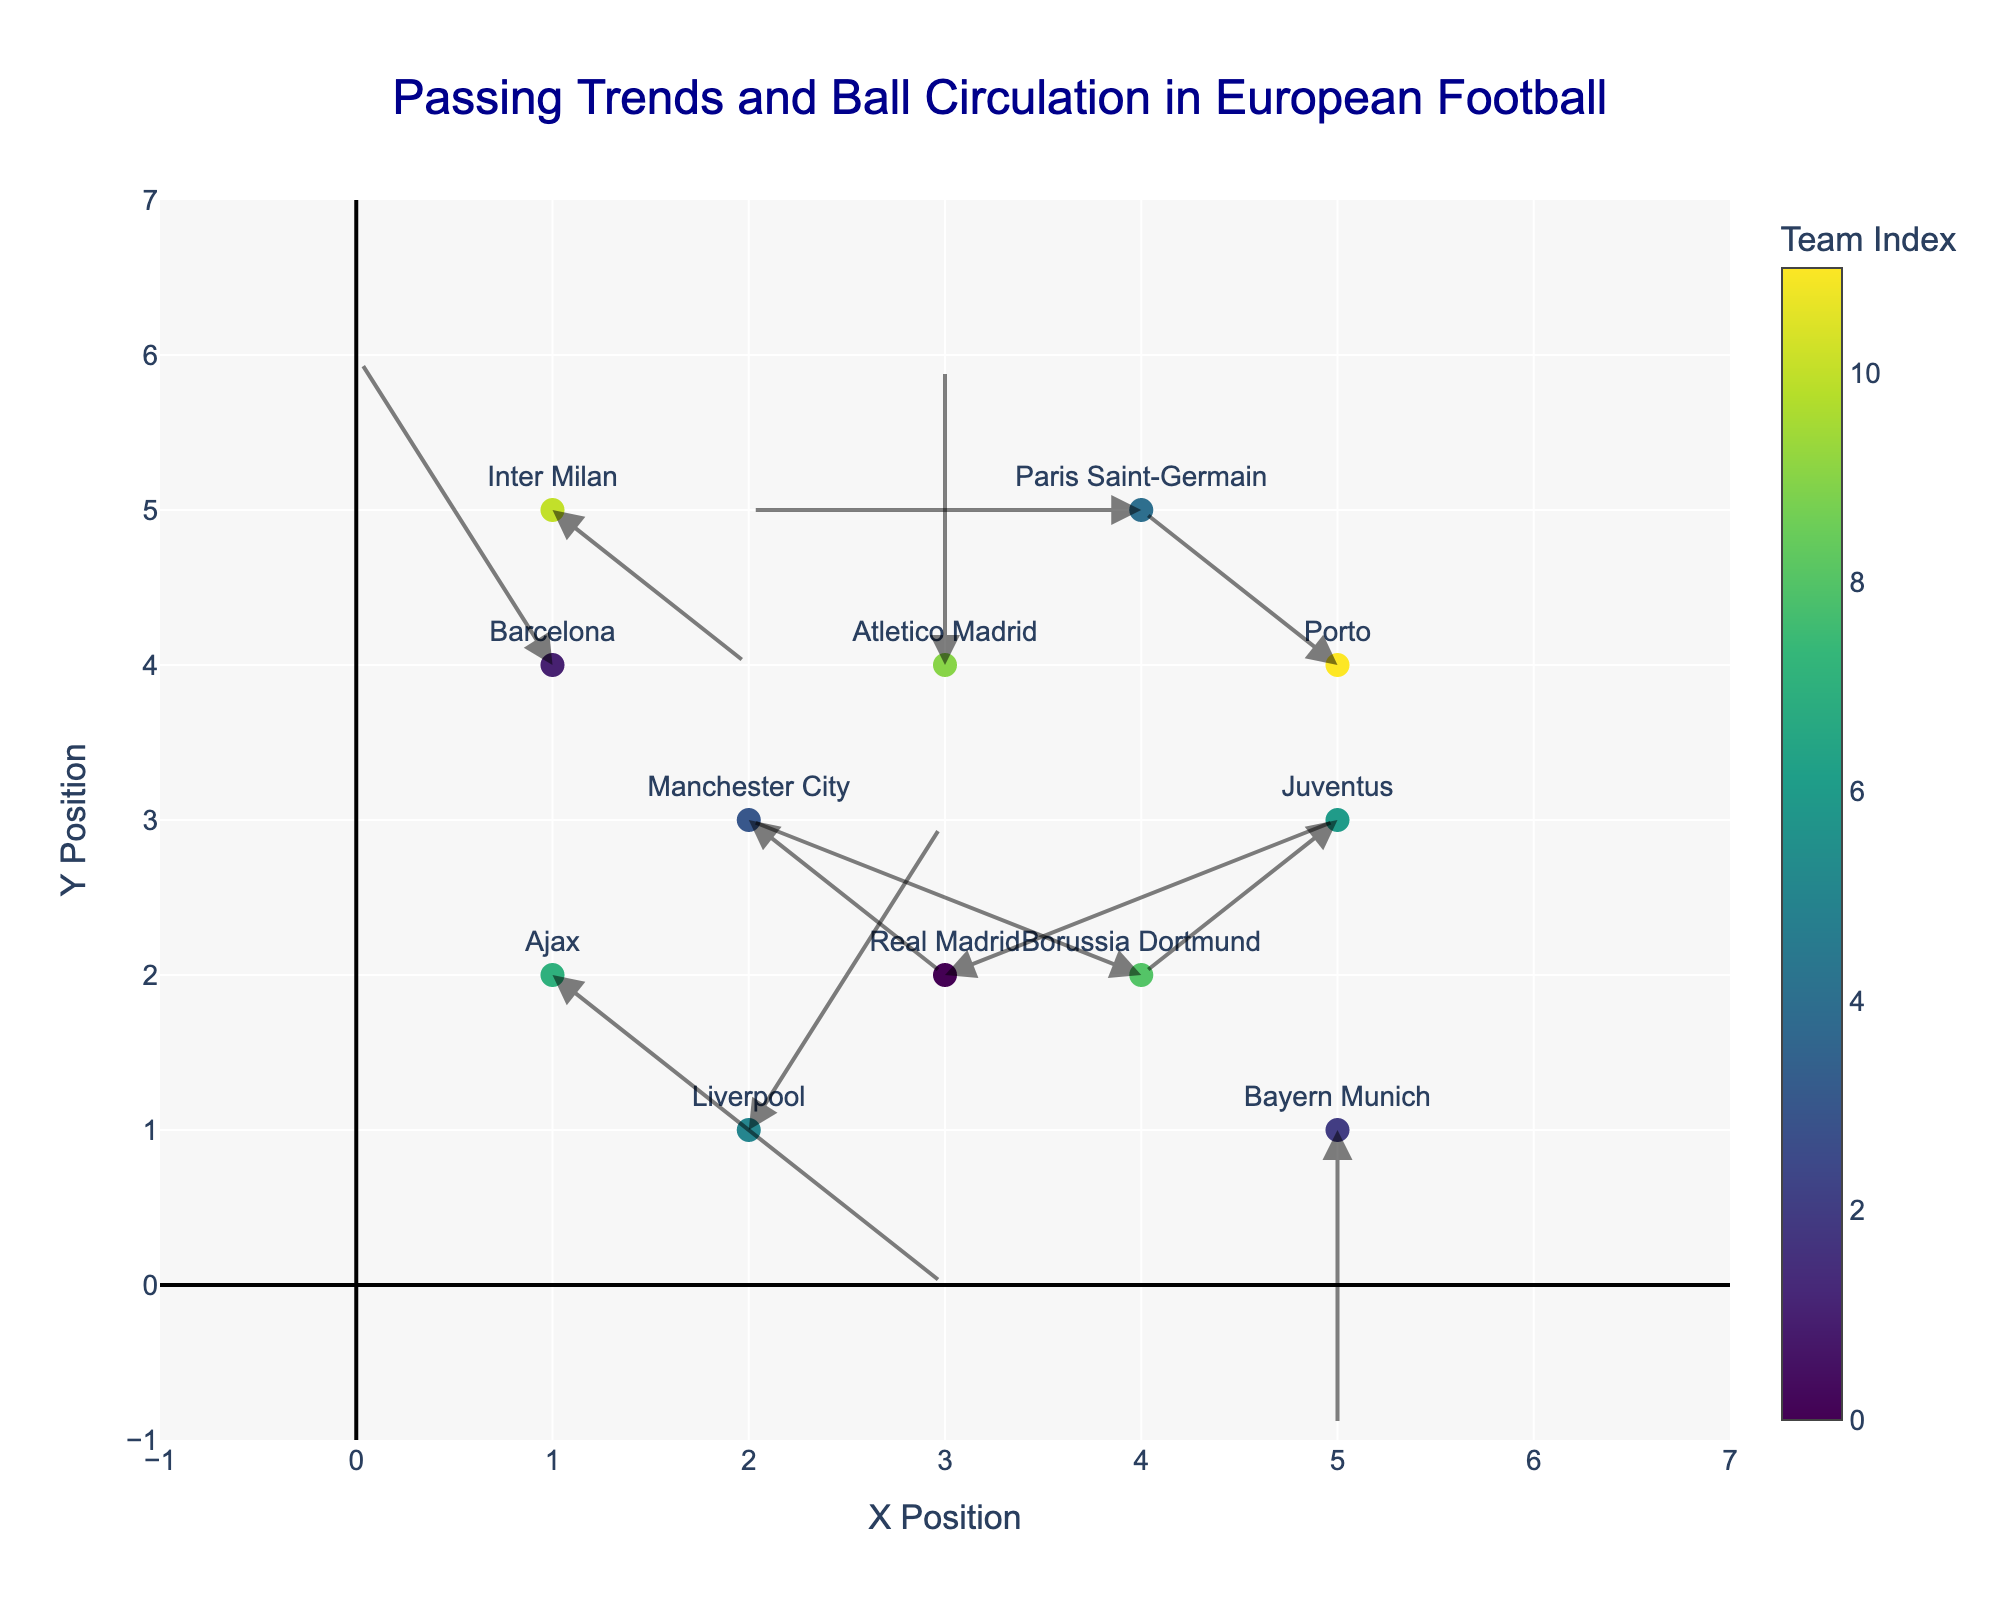What is the title of the figure? The title of the figure is displayed at the top of the plot area, and it is formatted with a larger font size and a distinct color to make it stand out. It reads, "Passing Trends and Ball Circulation in European Football."
Answer: Passing Trends and Ball Circulation in European Football How many teams are represented in the figure? Count the number of distinct markers (both points and arrows) with team names beside them. The data includes multiple teams, so you need to cross-check with the annotations to confirm the count.
Answer: 12 Which team has a passing direction exactly along the y-axis? Look for a team whose arrow direction represents zero horizontal movement (u=0) and some vertical movement. In this case, examine the arrows to find Bayern Munich (u=0, v=-2).
Answer: Bayern Munich Which team has a negative horizontal passing trend but no vertical movement? Look for the team whose horizontal component (u) is negative and vertical component (v) is zero. Paris Saint-Germain fits this description with (u=-2, v=0).
Answer: Paris Saint-Germain Compare the passing trends of Ajax and Inter Milan. Which team shows a downward trend in their passing? Analyze the direction of the arrows for both teams. Ajax has and Inter Milan has determining the downward trend through v and y components. Note Ajax has (u=2, v=-2) showing downward movement while Inter Milan has (u=1, v=-1) also showing a downward trend. So both show downward trends but Ajax has a steeper one.
Answer: Both, but Ajax has a steeper downward trend What is the overall movement (u, v) of Real Madrid and how does it compare to Liverpool's movement? For Real Madrid, we have (u=2, v=1) and for Liverpool, (u=1, v=2). Comparing both vectors, Real Madrid has a more horizontal movement while Liverpool has a stronger vertical movement.
Answer: Real Madrid has more horizontal movement; Liverpool has more vertical movement What's the combined passing vector (u, v) for all the teams with negative horizontal passing trends? First identify teams with negative u, those are Barcelona (u=-1), Paris Saint-Germain (u=-2), Juventus (u=-1), Borussia Dortmund (u=-2), Porto (u=-1). Then sum their u and v components:
u_total = -1 + -2 + -1 + -2 + -1 = -7;
v_total = 2 + 0 + -1 + 1 + 1 = 3
Answer: (-7, 3) Which team has the most variability in both its x and y components (furthest vector)? Identify the team with the greatest combined movement in u and v by computing the magnitude (sqrt(u^2 + v^2)). Check each team's movement:
- Real Madrid: sqrt(2^2 + 1^2) = sqrt(5)
- Barcelona: sqrt((-1)^2 + 2^2) = sqrt(5)
- Bayern Munich: sqrt(0^2 + (-2)^2) = 2
- Manchester City: sqrt(1^2 + (-1)^2) = sqrt(2)
- Paris Saint-Germain: sqrt((-2)^2 + 0^2) = 2
- Liverpool: sqrt(1^2 + 2^2) = sqrt(5)
- Juventus: sqrt((-1)^2 + (-1)^2) = sqrt(2)
- Ajax: sqrt(2^2 + (-2)^2) = sqrt(8)
- Borussia Dortmund: sqrt((-2)^2 + 1^2) = sqrt(5)
- Atletico Madrid: sqrt(0^2 + 2^2) = 2
- Inter Milan: sqrt(1^2 + (-1)^2) = sqrt(2)
- Porto: sqrt((-1)^2 + 1^2) = sqrt(2)
Ajax has the highest variability with sqrt(8) ≈ 2.83.
Answer: Ajax 